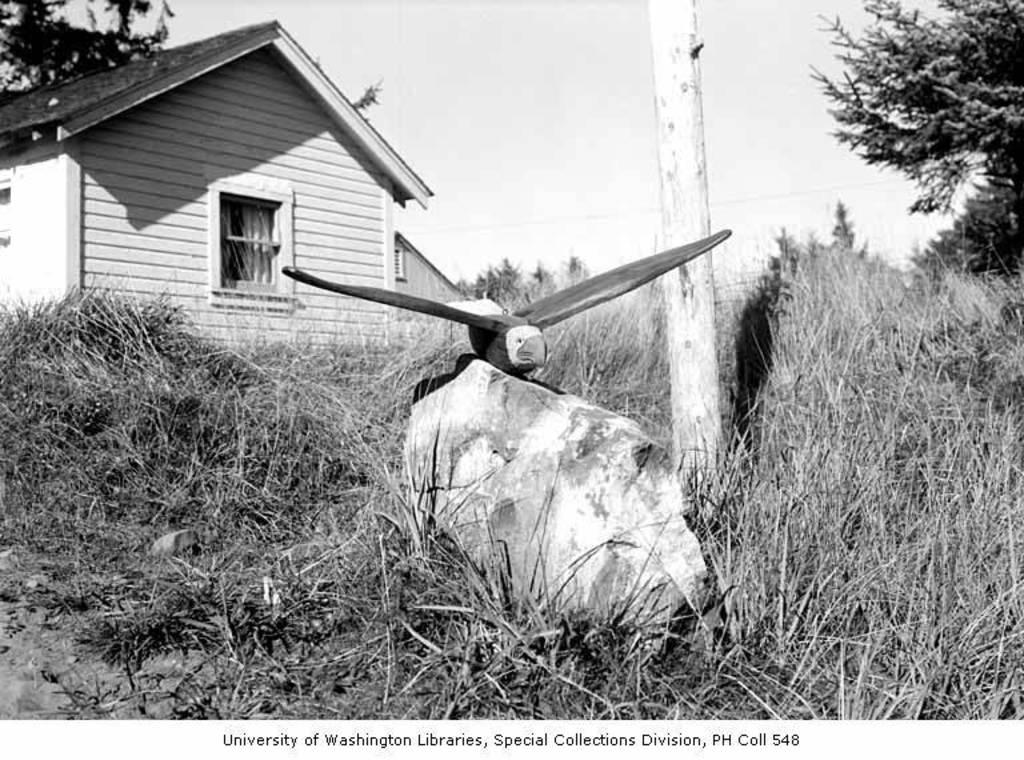<image>
Summarize the visual content of the image. A picture of a house is from the University of Washington Libraries. 